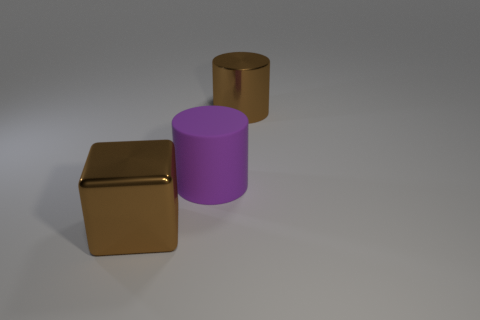There is a brown thing that is in front of the metallic object on the right side of the block; how big is it?
Your answer should be very brief. Large. How many other things are there of the same size as the brown cylinder?
Make the answer very short. 2. What number of large shiny cylinders are there?
Your answer should be very brief. 1. Is the size of the brown shiny cylinder the same as the brown block?
Keep it short and to the point. Yes. What number of other things are there of the same shape as the matte thing?
Keep it short and to the point. 1. The large purple cylinder that is to the right of the big brown thing to the left of the purple rubber cylinder is made of what material?
Give a very brief answer. Rubber. There is a brown metal cylinder; are there any large metallic things left of it?
Ensure brevity in your answer.  Yes. There is a purple matte thing; does it have the same size as the metallic object that is on the right side of the purple thing?
Your response must be concise. Yes. What is the size of the brown thing that is the same shape as the purple object?
Make the answer very short. Large. Is there anything else that has the same material as the big brown cube?
Offer a very short reply. Yes. 